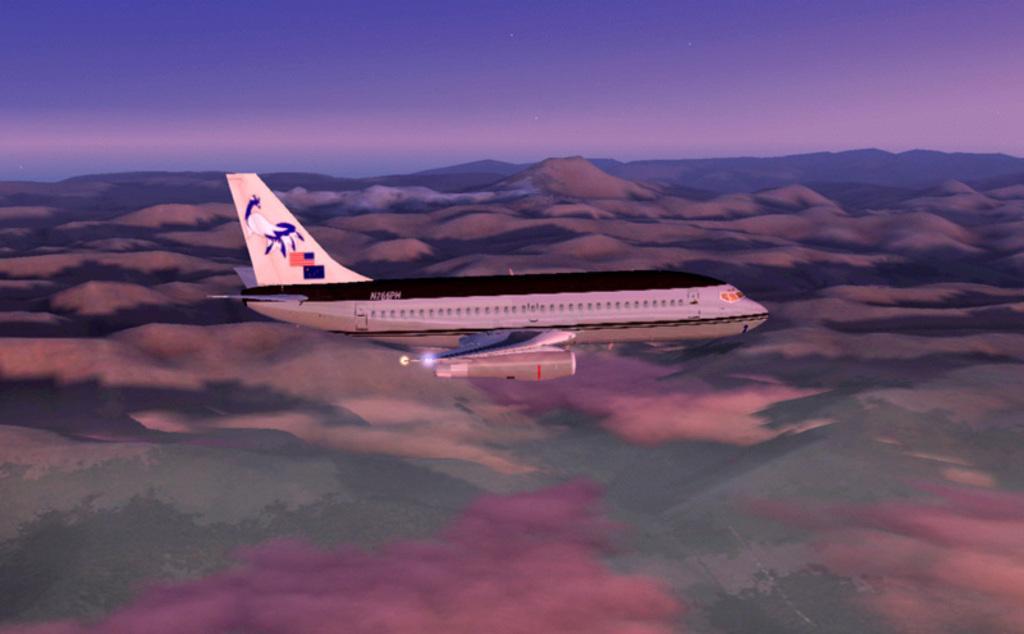Please provide a concise description of this image. In the image there is an airplane flying in the air and below there are hills on the land and above its sky. 